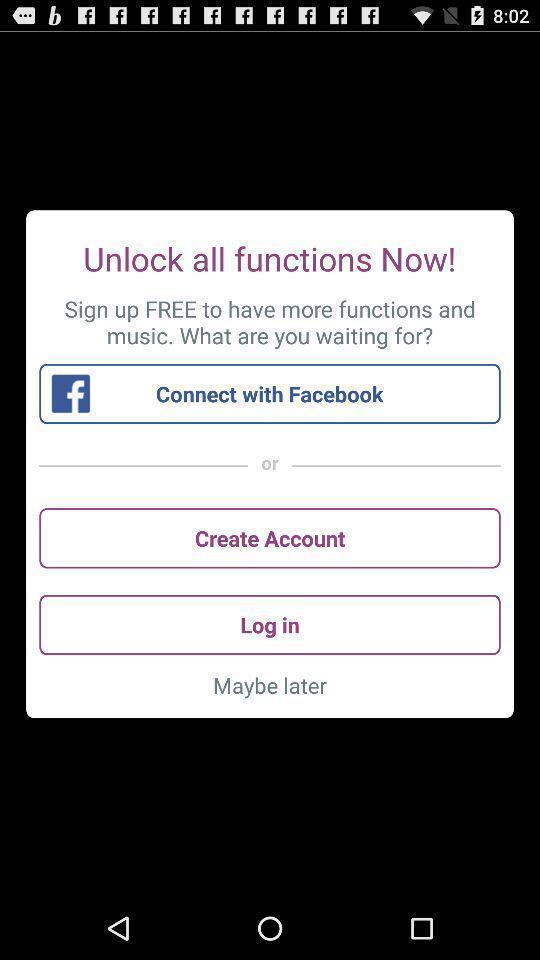Describe the visual elements of this screenshot. Screen displaying the login page. 